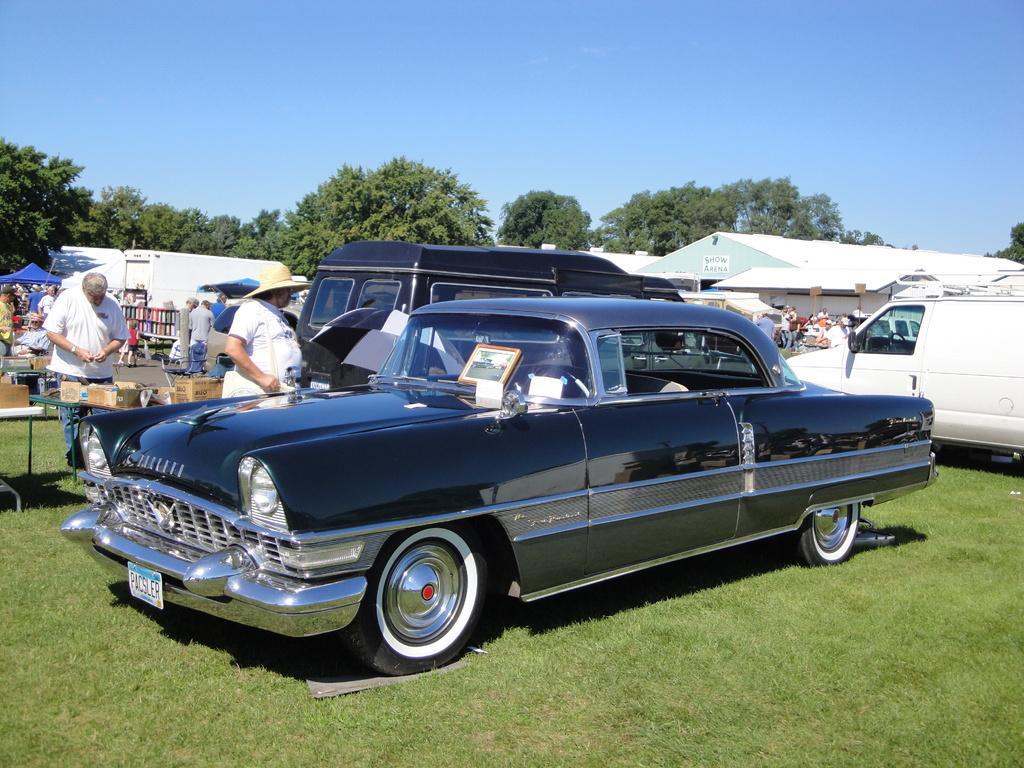How would you summarize this image in a sentence or two? In the center of the image we can see car on the grass. In the background we can see cars, persons, tents, sheds, road, objects arranged in shelves, trees and sky. 